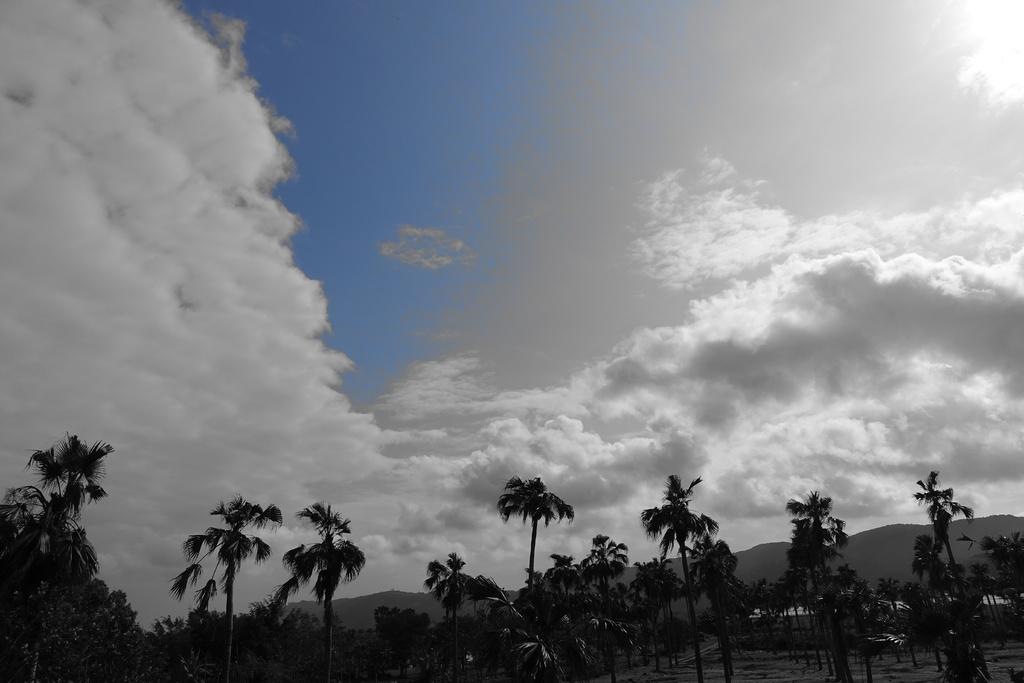What type of vegetation can be seen in the image? There are trees in the image. What type of geographical feature is present in the image? There are hills in the image. What is visible in the background of the image? The sky is visible in the background of the image. What can be seen in the sky in the background of the image? Clouds are present in the sky in the background of the image. Can you tell me how many agreements were signed on the cherry tree in the image? There is no cherry tree or any agreements present in the image. How many planes can be seen flying in the sky in the image? There are no planes visible in the sky in the image. 